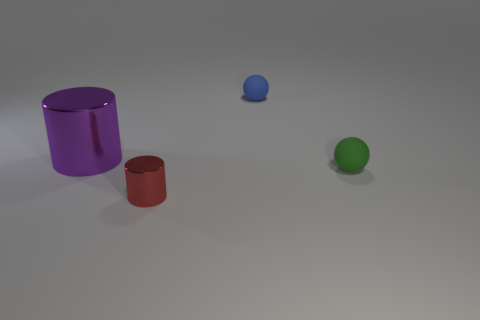Are there any blue things of the same shape as the purple metallic object?
Offer a terse response. No. Are there the same number of small matte objects to the left of the small green sphere and big cyan cubes?
Provide a short and direct response. No. What number of blue things have the same size as the green matte ball?
Offer a very short reply. 1. What number of red metal objects are to the right of the small green matte object?
Make the answer very short. 0. What material is the big purple thing behind the tiny thing that is on the left side of the tiny blue rubber ball made of?
Your answer should be very brief. Metal. Are there any tiny matte objects that have the same color as the big cylinder?
Offer a terse response. No. What is the size of the other object that is the same material as the small blue object?
Offer a very short reply. Small. Is there anything else of the same color as the large metallic cylinder?
Provide a short and direct response. No. The metal cylinder that is right of the big metal cylinder is what color?
Offer a terse response. Red. Are there any big purple cylinders in front of the cylinder in front of the big metallic cylinder that is in front of the blue rubber ball?
Ensure brevity in your answer.  No. 